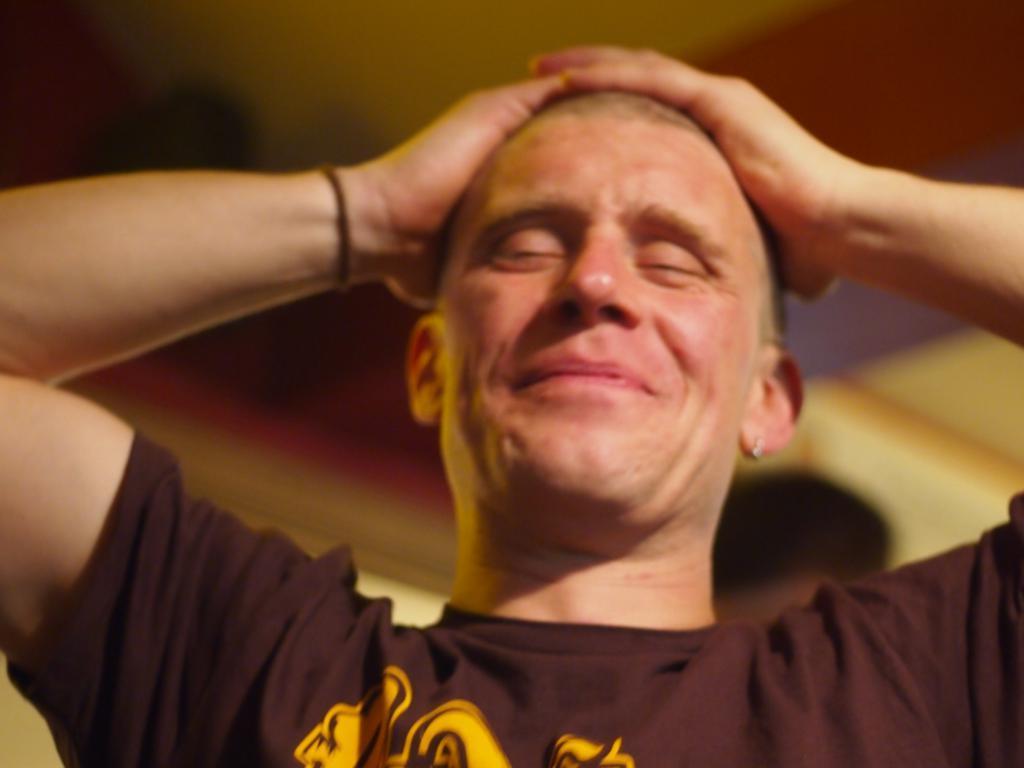Please provide a concise description of this image. In this picture there is a man wore t shirt. In the background of the image it is blurry and we can see a person. 